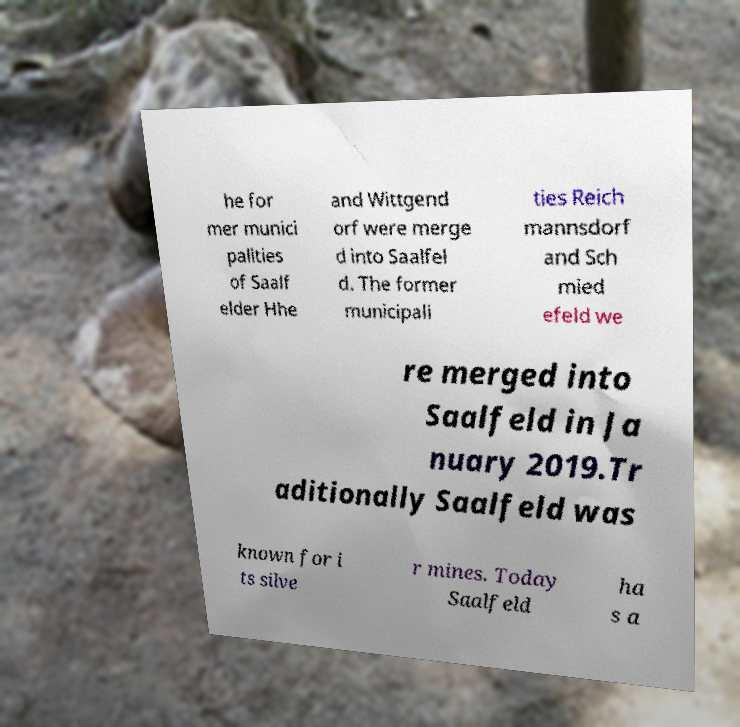Please read and relay the text visible in this image. What does it say? he for mer munici palities of Saalf elder Hhe and Wittgend orf were merge d into Saalfel d. The former municipali ties Reich mannsdorf and Sch mied efeld we re merged into Saalfeld in Ja nuary 2019.Tr aditionally Saalfeld was known for i ts silve r mines. Today Saalfeld ha s a 